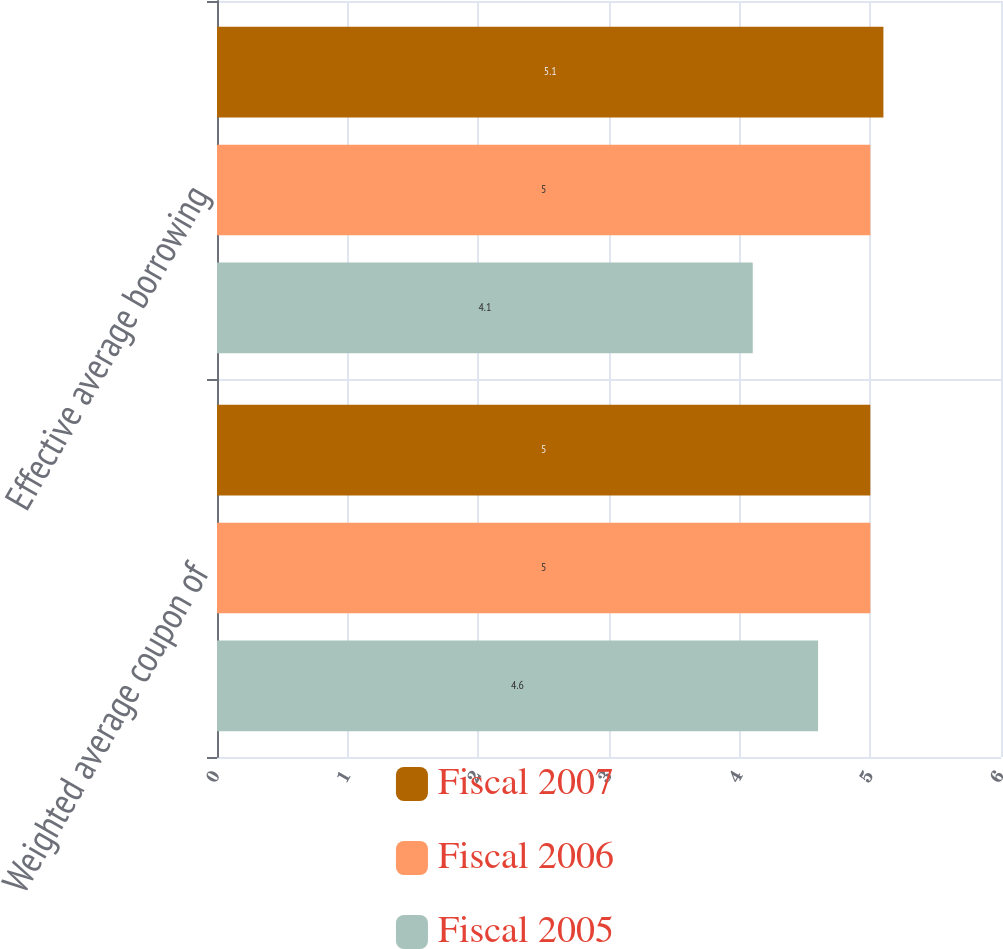Convert chart. <chart><loc_0><loc_0><loc_500><loc_500><stacked_bar_chart><ecel><fcel>Weighted average coupon of<fcel>Effective average borrowing<nl><fcel>Fiscal 2007<fcel>5<fcel>5.1<nl><fcel>Fiscal 2006<fcel>5<fcel>5<nl><fcel>Fiscal 2005<fcel>4.6<fcel>4.1<nl></chart> 